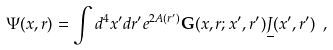<formula> <loc_0><loc_0><loc_500><loc_500>\Psi ( x , r ) = \int d ^ { 4 } x ^ { \prime } d r ^ { \prime } e ^ { 2 A ( r ^ { \prime } ) } { \mathbf G } ( x , r ; x ^ { \prime } , r ^ { \prime } ) \underline { J } ( x ^ { \prime } , r ^ { \prime } ) \ ,</formula> 